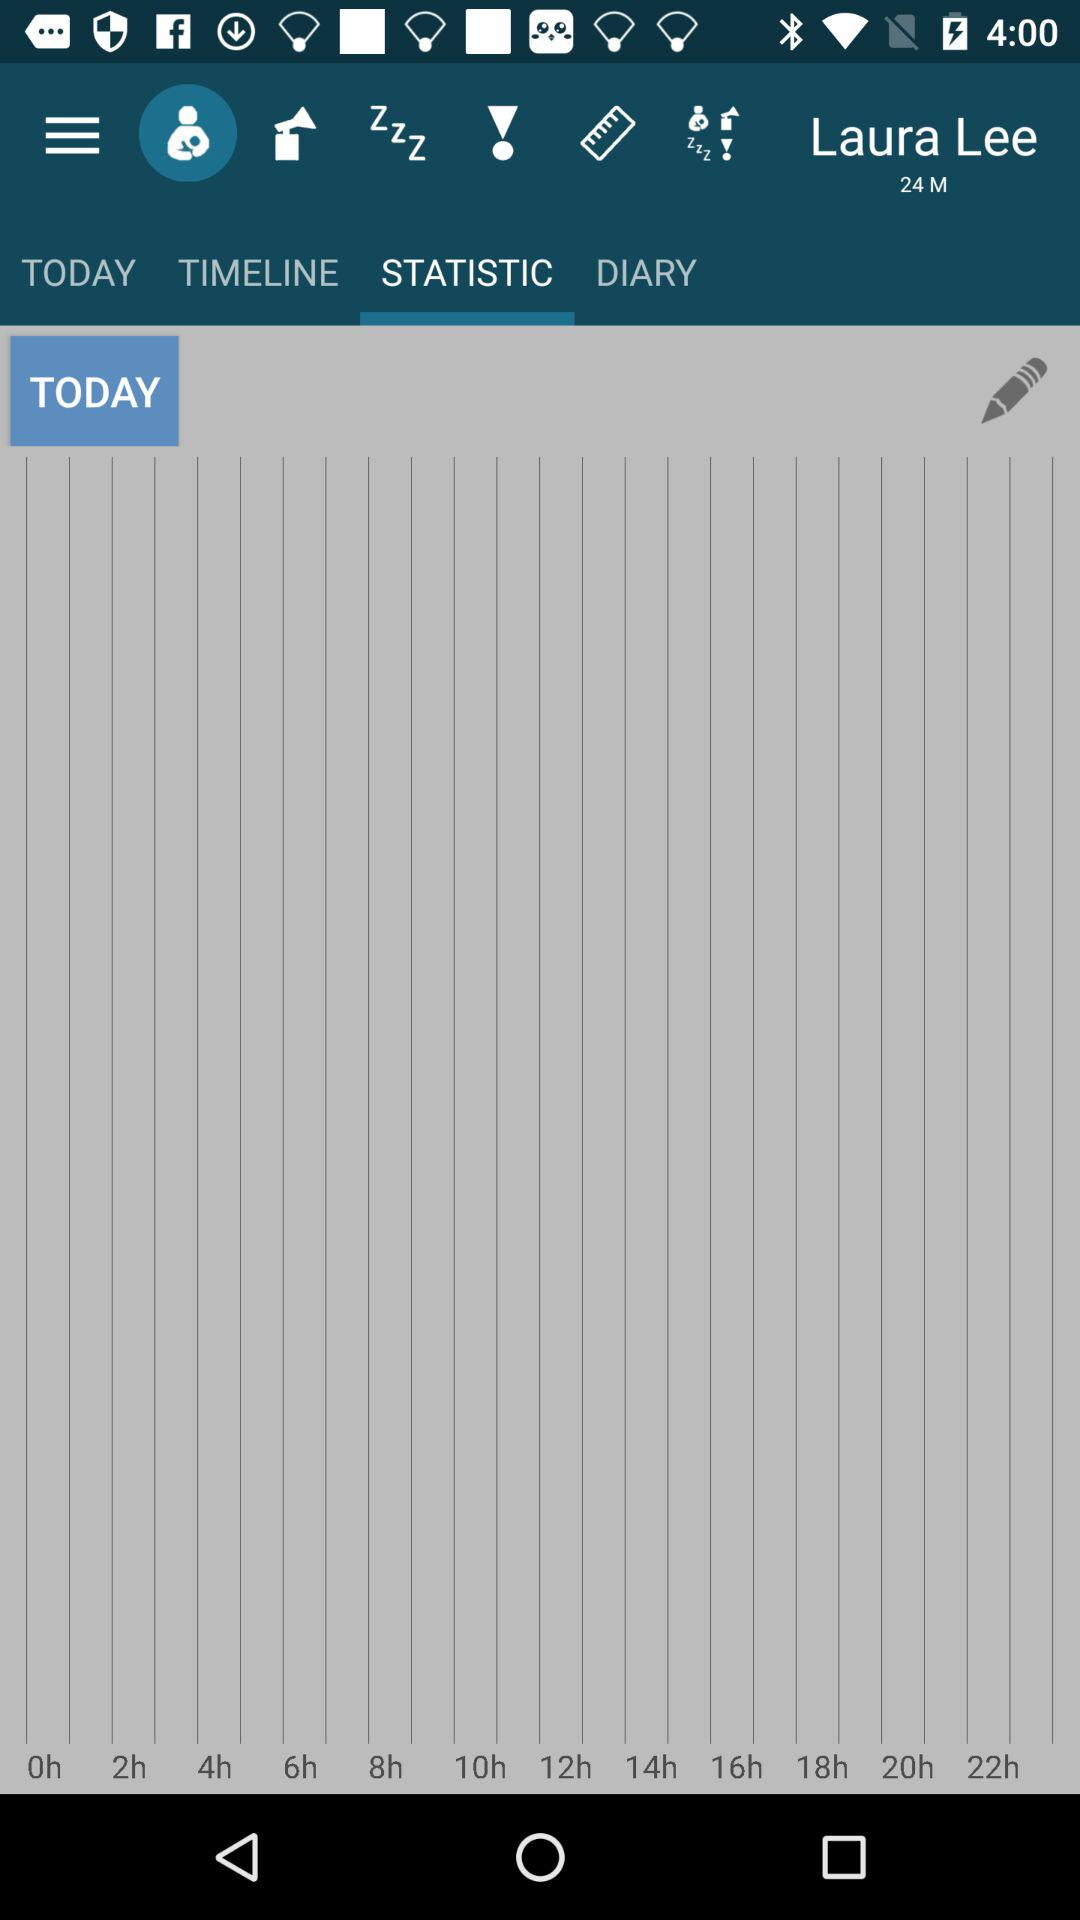What day is it shown? The day is "TODAY". 